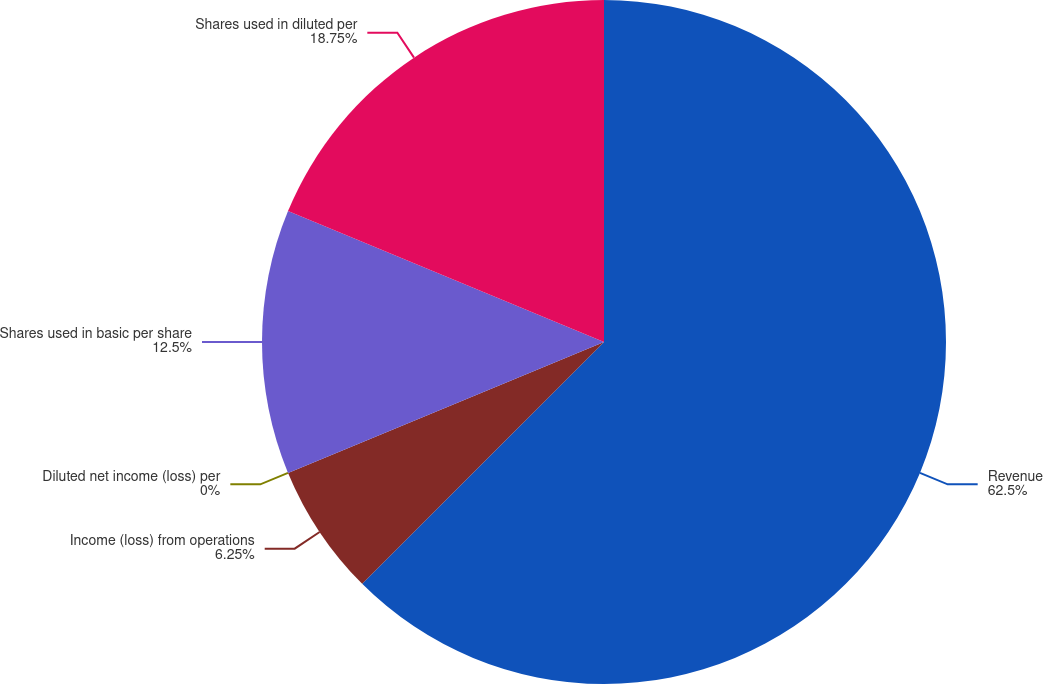Convert chart. <chart><loc_0><loc_0><loc_500><loc_500><pie_chart><fcel>Revenue<fcel>Income (loss) from operations<fcel>Diluted net income (loss) per<fcel>Shares used in basic per share<fcel>Shares used in diluted per<nl><fcel>62.5%<fcel>6.25%<fcel>0.0%<fcel>12.5%<fcel>18.75%<nl></chart> 